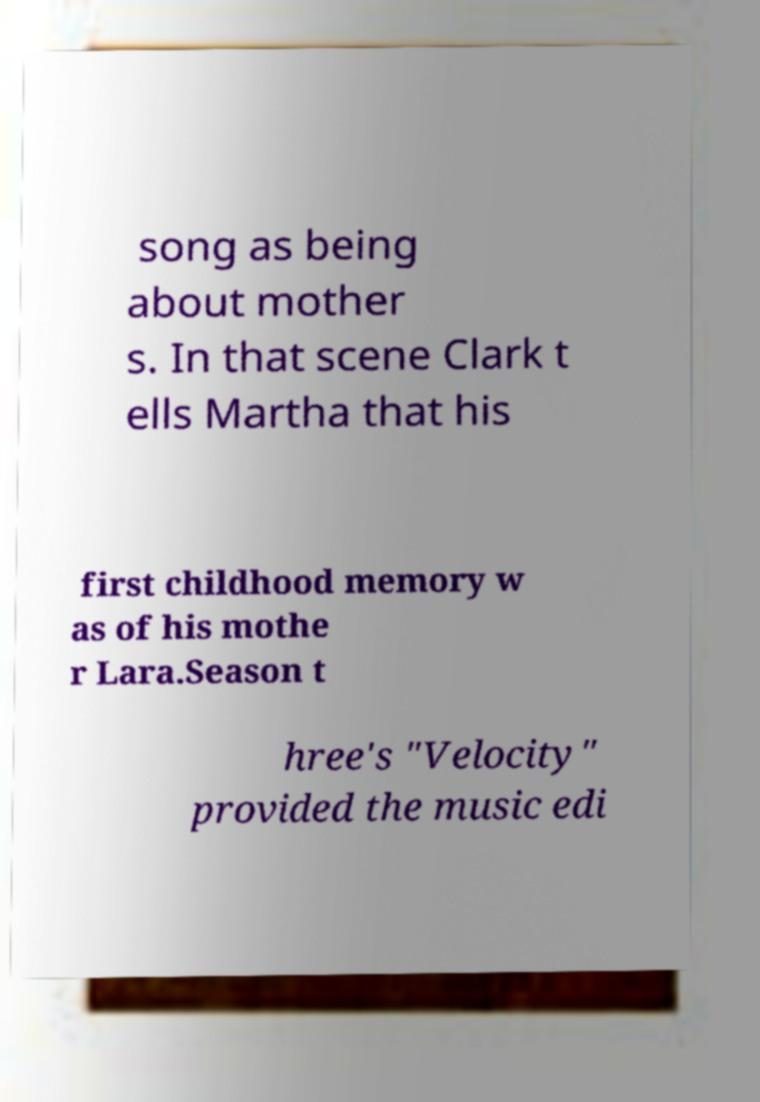Could you assist in decoding the text presented in this image and type it out clearly? song as being about mother s. In that scene Clark t ells Martha that his first childhood memory w as of his mothe r Lara.Season t hree's "Velocity" provided the music edi 